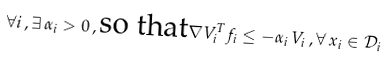Convert formula to latex. <formula><loc_0><loc_0><loc_500><loc_500>\forall i \, , \exists \, \alpha _ { i } > 0 \, , \text {so that} \nabla V _ { i } ^ { T } f _ { i } \leq - \alpha _ { i } \, V _ { i } \, , \forall \, x _ { i } \in \mathcal { D } _ { i }</formula> 